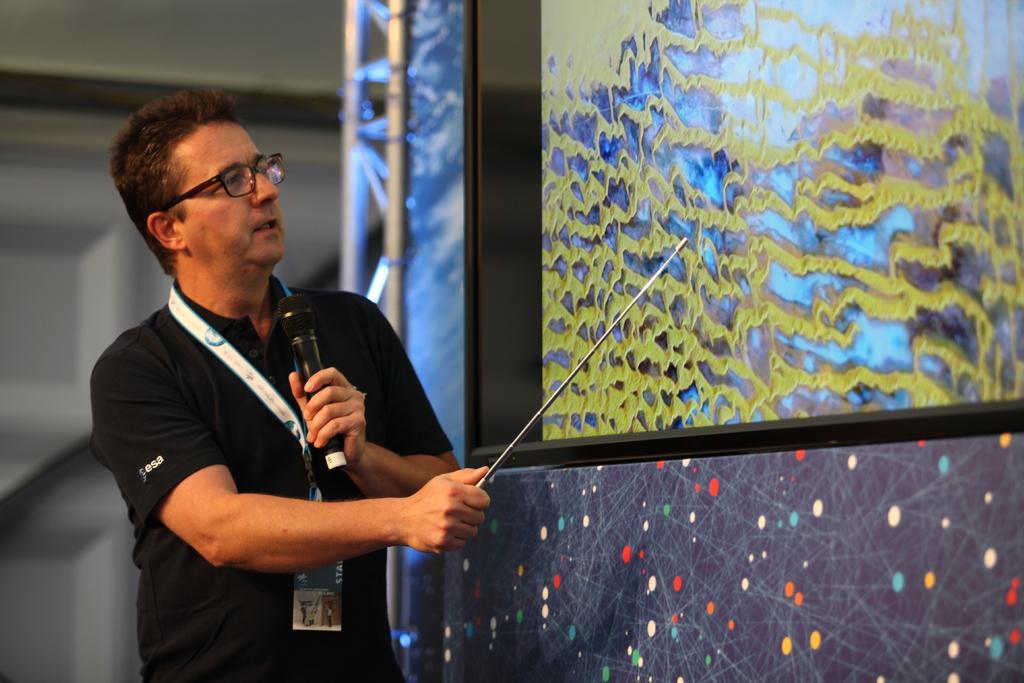How would you summarize this image in a sentence or two? On the left side of the image we can see one person standing and he is holding a stick and a microphone. And we can see he is wearing glasses. In front of him, we can see one screen, banner, pole type structure, wall and a few other objects. 